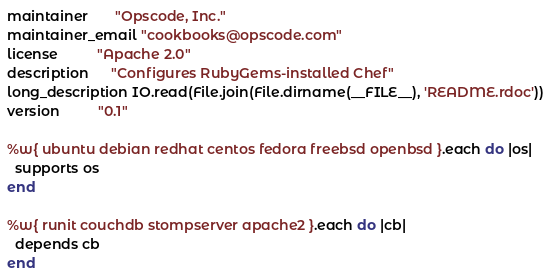Convert code to text. <code><loc_0><loc_0><loc_500><loc_500><_Ruby_>maintainer       "Opscode, Inc."
maintainer_email "cookbooks@opscode.com"
license          "Apache 2.0"
description      "Configures RubyGems-installed Chef"
long_description IO.read(File.join(File.dirname(__FILE__), 'README.rdoc'))
version          "0.1"

%w{ ubuntu debian redhat centos fedora freebsd openbsd }.each do |os|
  supports os
end

%w{ runit couchdb stompserver apache2 }.each do |cb|
  depends cb
end
</code> 